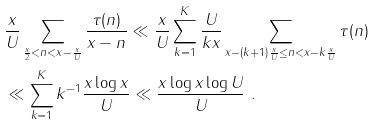<formula> <loc_0><loc_0><loc_500><loc_500>& \frac { x } { U } \sum _ { \frac { x } { 2 } < n < x - \frac { x } { U } } \frac { \tau ( n ) } { x - n } \ll \frac { x } { U } \sum _ { k = 1 } ^ { K } \frac { U } { k x } \sum _ { x - ( k + 1 ) \frac { x } { U } \leq n < x - k \frac { x } { U } } \tau ( n ) \\ & \ll \sum _ { k = 1 } ^ { K } k ^ { - 1 } \frac { x \log x } { U } \ll \frac { x \log x \log U } { U } \ .</formula> 